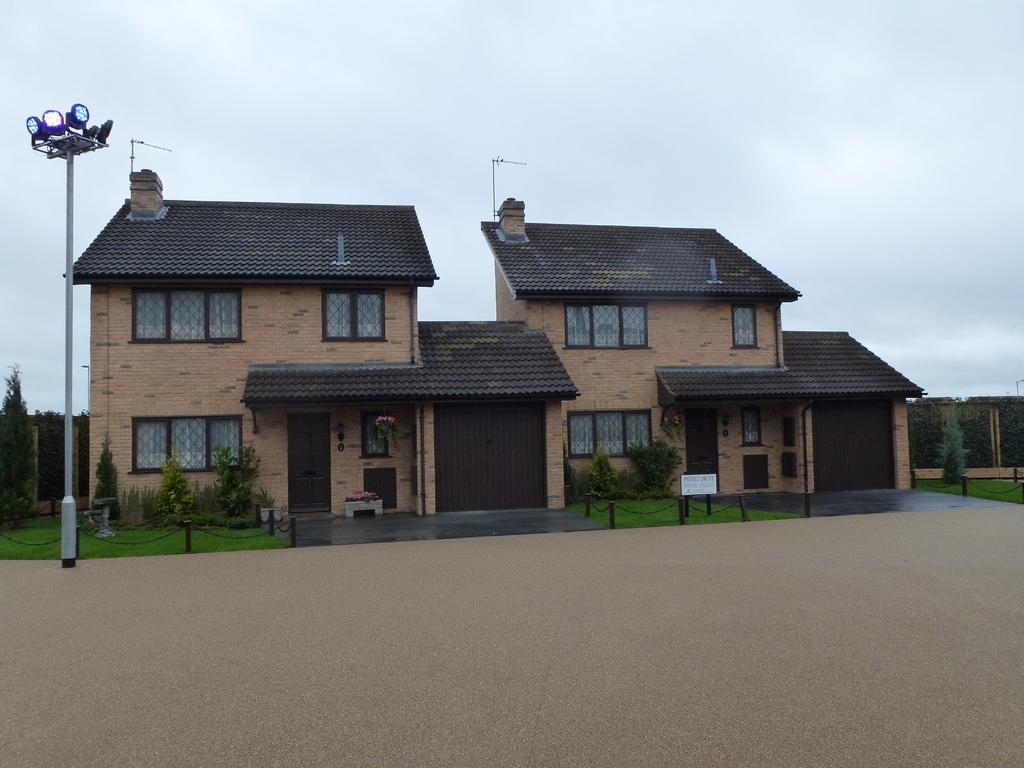Describe this image in one or two sentences. In the image there is a house and in front of the house there is an open land and there is a pole and there are different lights fit to the pole. 